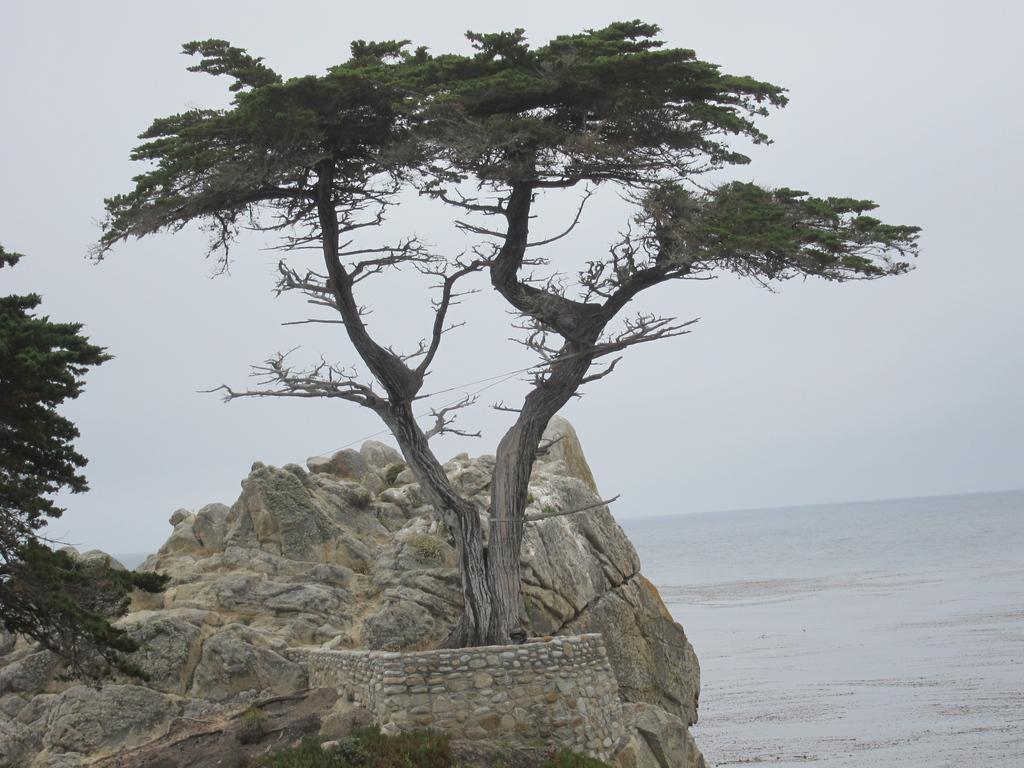Describe this image in one or two sentences. In the picture I can see the water on the right side. I can see the rock and trees. There are clouds in the sky. 